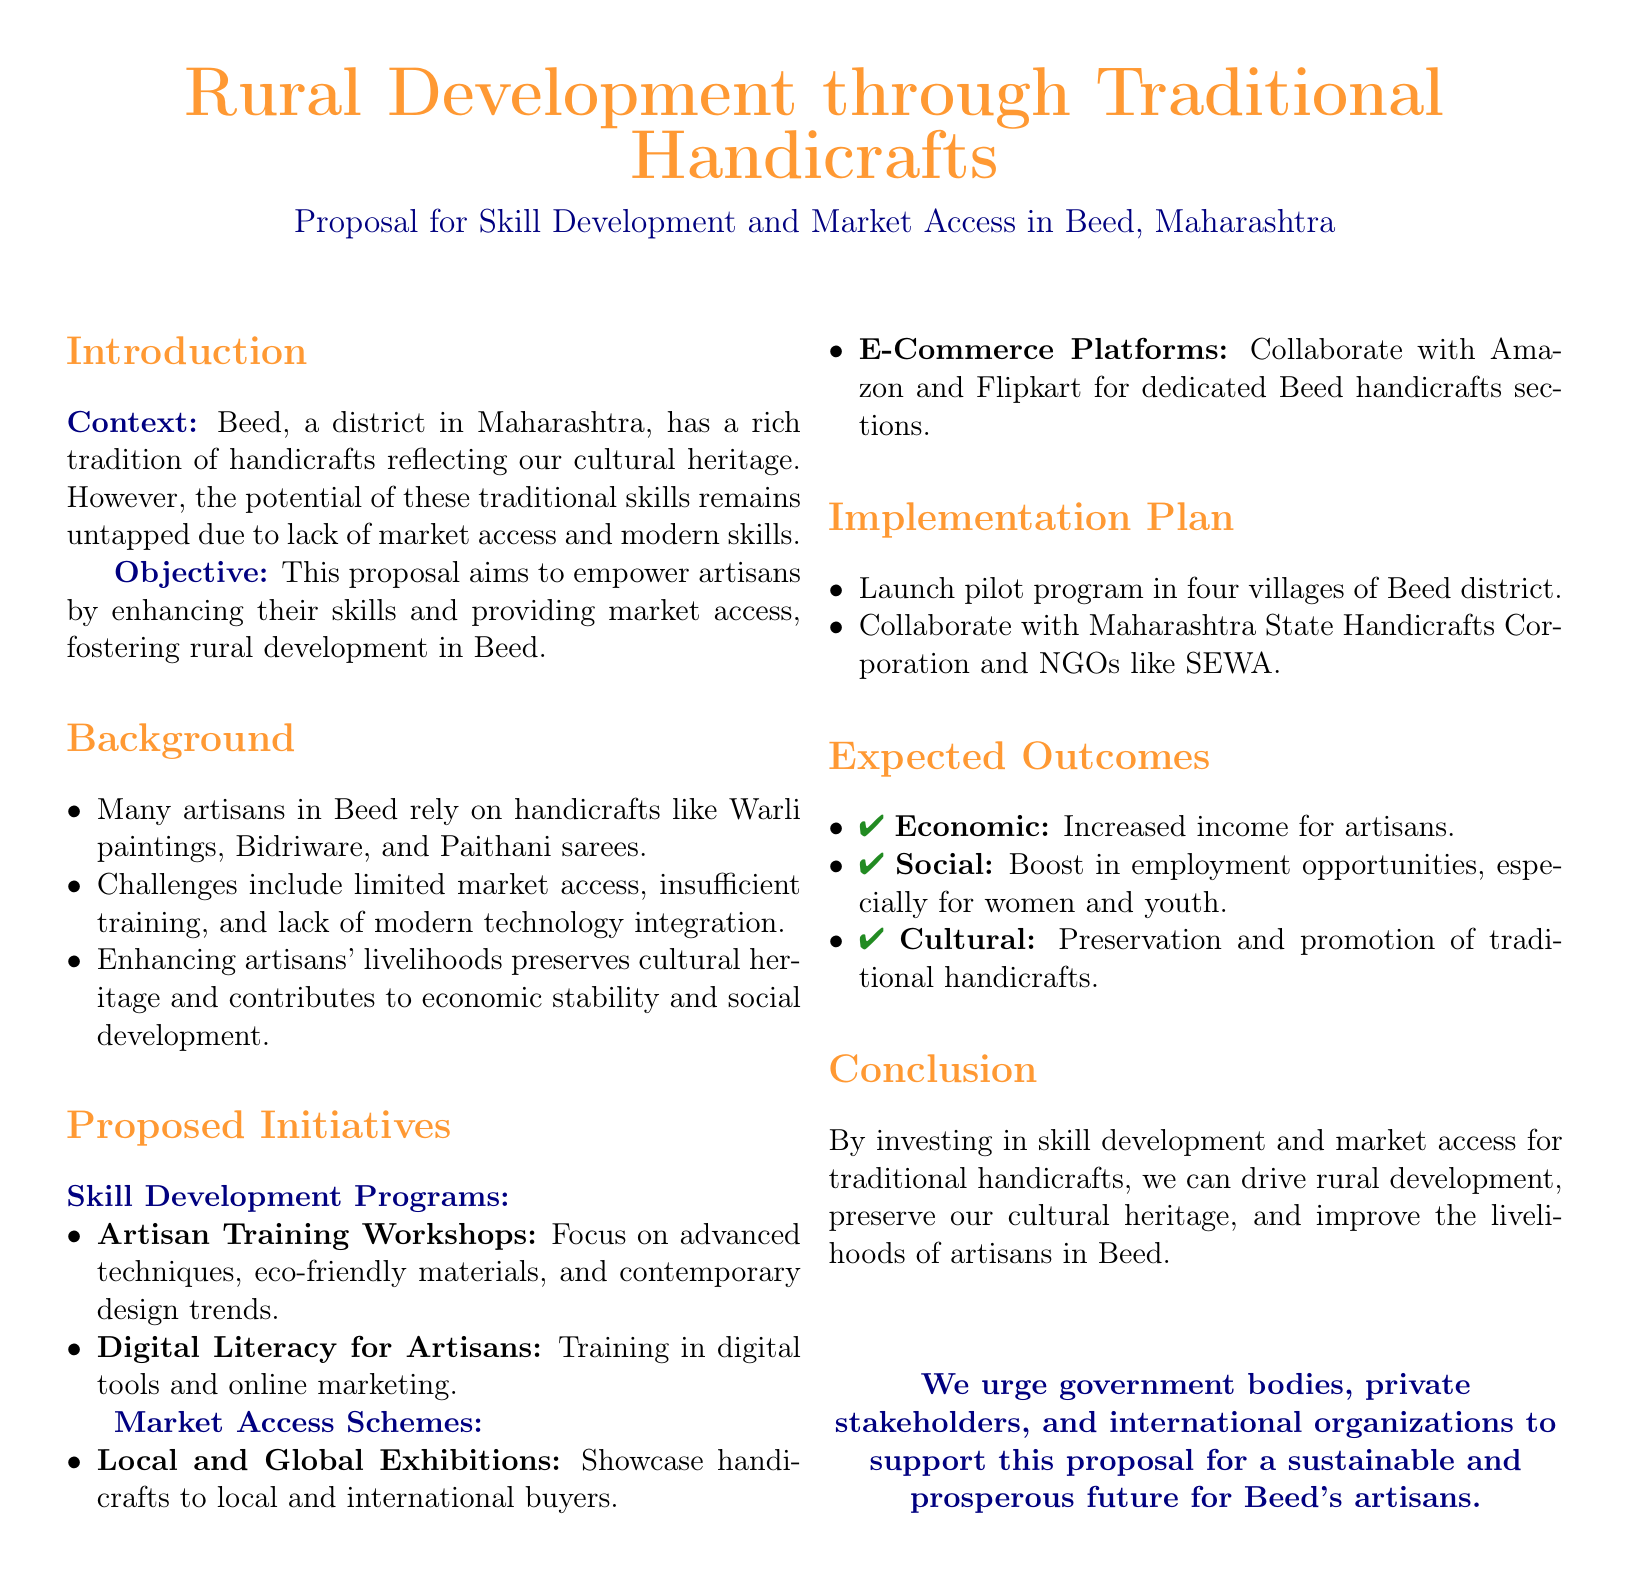What is the main objective of the proposal? The main objective is to empower artisans by enhancing their skills and providing market access.
Answer: Empower artisans What types of handicrafts are mentioned in the document? The document mentions Warli paintings, Bidriware, and Paithani sarees as traditional handicrafts in Beed.
Answer: Warli paintings, Bidriware, Paithani sarees Which organization is proposed to collaborate with for implementation? The proposal suggests collaborating with the Maharashtra State Handicrafts Corporation.
Answer: Maharashtra State Handicrafts Corporation What is one expected economic outcome mentioned in the proposal? An expected economic outcome is increased income for artisans.
Answer: Increased income What types of training are included in the Skill Development Programs? The Skill Development Programs include Artisan Training Workshops and Digital Literacy for Artisans.
Answer: Artisan Training Workshops, Digital Literacy for Artisans How many villages are planned for the pilot program launch? The pilot program is planned to be launched in four villages.
Answer: Four villages What kind of exhibitions are proposed under Market Access Schemes? The proposal includes local and global exhibitions to showcase handicrafts.
Answer: Local and global exhibitions Which stakeholders are urged to support the proposal? The proposal urges government bodies, private stakeholders, and international organizations to support it.
Answer: Government bodies, private stakeholders, international organizations 